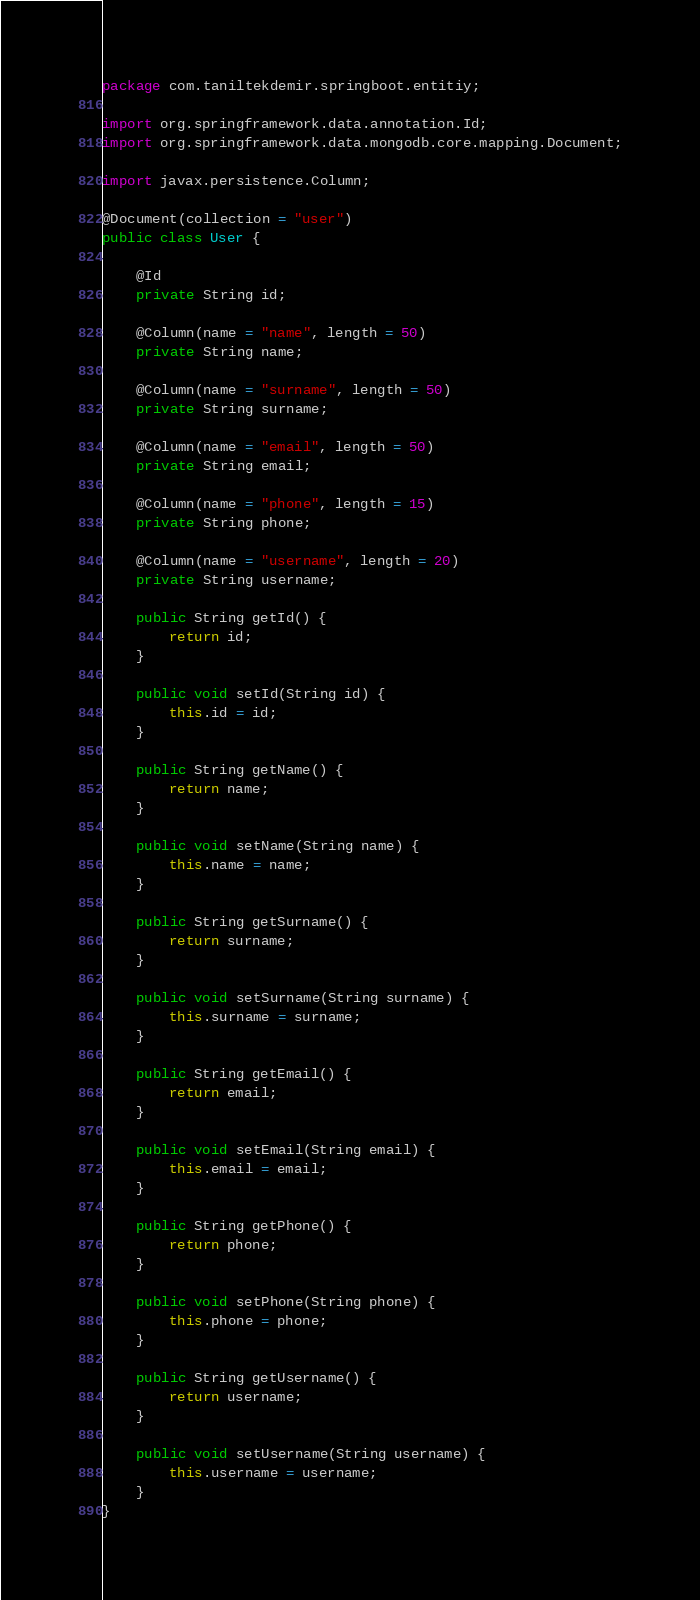Convert code to text. <code><loc_0><loc_0><loc_500><loc_500><_Java_>package com.taniltekdemir.springboot.entitiy;

import org.springframework.data.annotation.Id;
import org.springframework.data.mongodb.core.mapping.Document;

import javax.persistence.Column;

@Document(collection = "user")
public class User {

    @Id
    private String id;

    @Column(name = "name", length = 50)
    private String name;

    @Column(name = "surname", length = 50)
    private String surname;

    @Column(name = "email", length = 50)
    private String email;

    @Column(name = "phone", length = 15)
    private String phone;

    @Column(name = "username", length = 20)
    private String username;

    public String getId() {
        return id;
    }

    public void setId(String id) {
        this.id = id;
    }

    public String getName() {
        return name;
    }

    public void setName(String name) {
        this.name = name;
    }

    public String getSurname() {
        return surname;
    }

    public void setSurname(String surname) {
        this.surname = surname;
    }

    public String getEmail() {
        return email;
    }

    public void setEmail(String email) {
        this.email = email;
    }

    public String getPhone() {
        return phone;
    }

    public void setPhone(String phone) {
        this.phone = phone;
    }

    public String getUsername() {
        return username;
    }

    public void setUsername(String username) {
        this.username = username;
    }
}
</code> 